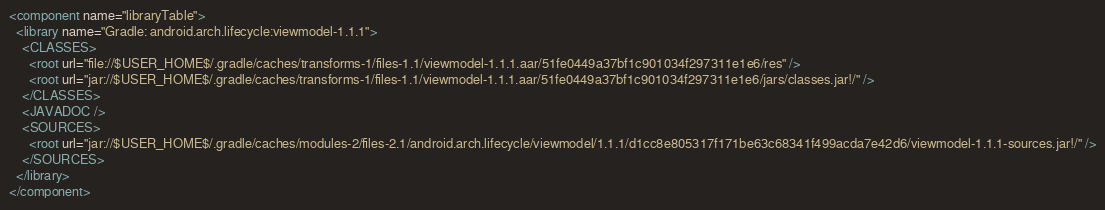Convert code to text. <code><loc_0><loc_0><loc_500><loc_500><_XML_><component name="libraryTable">
  <library name="Gradle: android.arch.lifecycle:viewmodel-1.1.1">
    <CLASSES>
      <root url="file://$USER_HOME$/.gradle/caches/transforms-1/files-1.1/viewmodel-1.1.1.aar/51fe0449a37bf1c901034f297311e1e6/res" />
      <root url="jar://$USER_HOME$/.gradle/caches/transforms-1/files-1.1/viewmodel-1.1.1.aar/51fe0449a37bf1c901034f297311e1e6/jars/classes.jar!/" />
    </CLASSES>
    <JAVADOC />
    <SOURCES>
      <root url="jar://$USER_HOME$/.gradle/caches/modules-2/files-2.1/android.arch.lifecycle/viewmodel/1.1.1/d1cc8e805317f171be63c68341f499acda7e42d6/viewmodel-1.1.1-sources.jar!/" />
    </SOURCES>
  </library>
</component></code> 